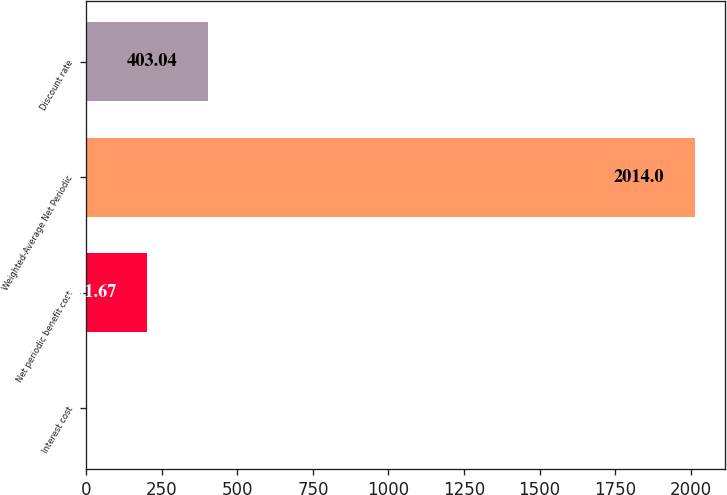Convert chart. <chart><loc_0><loc_0><loc_500><loc_500><bar_chart><fcel>Interest cost<fcel>Net periodic benefit cost<fcel>Weighted-Average Net Periodic<fcel>Discount rate<nl><fcel>0.3<fcel>201.67<fcel>2014<fcel>403.04<nl></chart> 